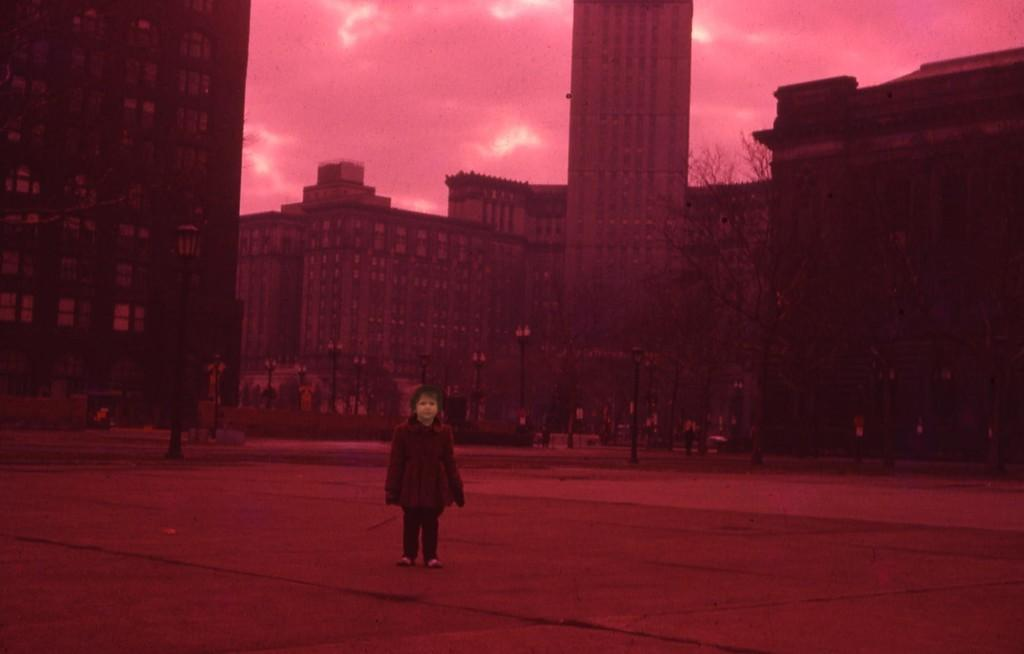What is the girl doing in the image? The girl is standing on the road in the image. What can be seen in the background of the image? There are buildings, trees, and street light poles in the background. What is visible at the top of the image? The sky is visible at the top of the image. What type of pan is the girl using to cook in the image? There is no pan or cooking activity present in the image. What is the girl holding in her hand in the image? The image does not show the girl holding anything in her hand. 